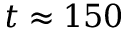<formula> <loc_0><loc_0><loc_500><loc_500>t \approx 1 5 0</formula> 